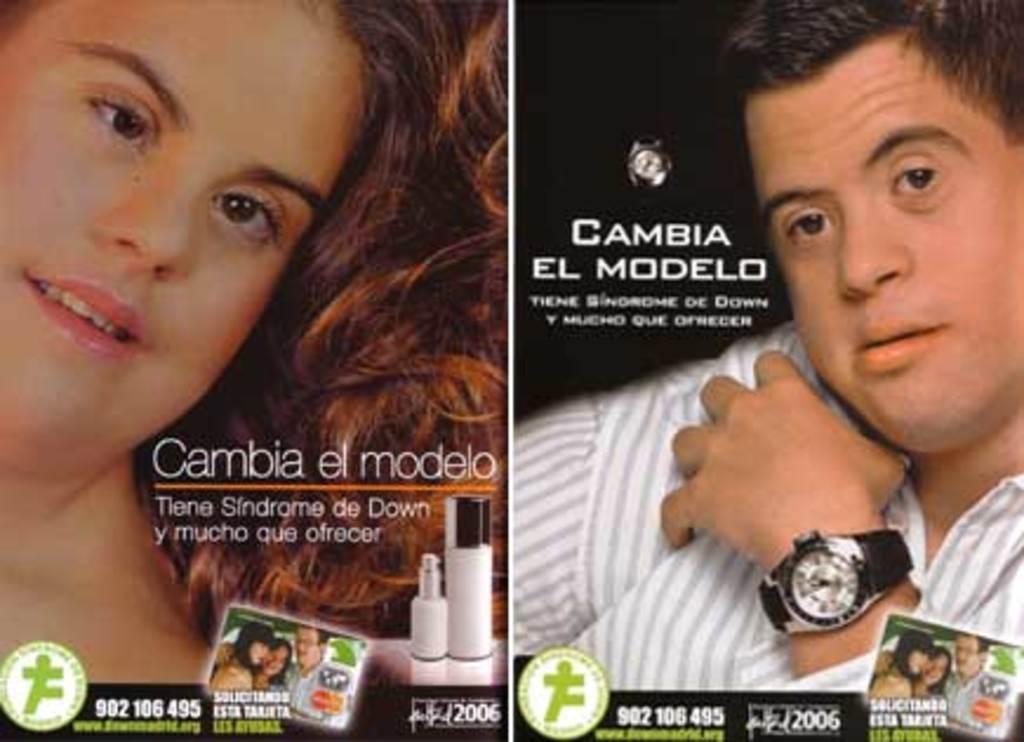What is the phone number?
Offer a terse response. 902 106 495. This is cambia?
Ensure brevity in your answer.  Yes. 